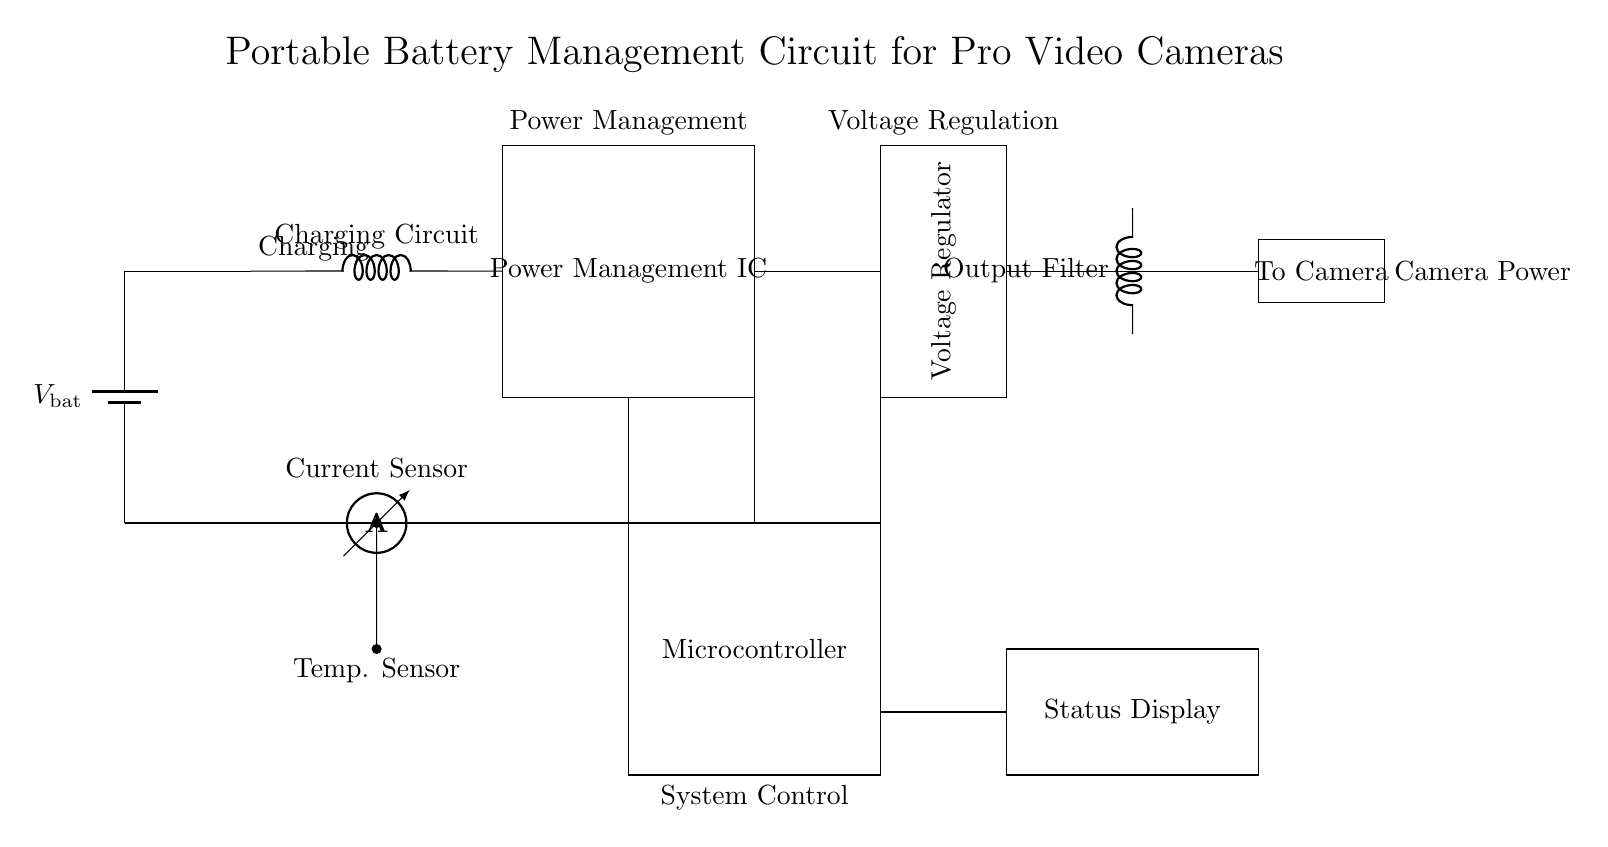What is the main purpose of the circuit? The circuit is designed to manage the battery for professional video cameras, ensuring proper charging and voltage regulation.
Answer: Battery management What type of component is the main controller? The main controller in the circuit is the microcontroller, which manages system operations.
Answer: Microcontroller What is the function of the voltage regulator? The voltage regulator ensures that the output voltage to the video camera remains constant despite variations in input voltage or load conditions.
Answer: Output regulation How many sensors are present in this circuit? There are two sensors: a current sensor and a temperature sensor for monitoring performance and safety.
Answer: Two What role does the output filter play in the circuit? The output filter is used to smooth out the voltage provided to the camera, reducing ripple and noise in the output signal.
Answer: Noise filtration What is the range of the current sensor indicated in the circuit? The specific range of the current sensor is not directly indicated in the circuit diagram; it typically can measure the battery's charging and discharging currents.
Answer: Variable range What does the status display indicate? The status display provides visual feedback about the battery and charging status, allowing users to monitor circuit performance easily.
Answer: System status 